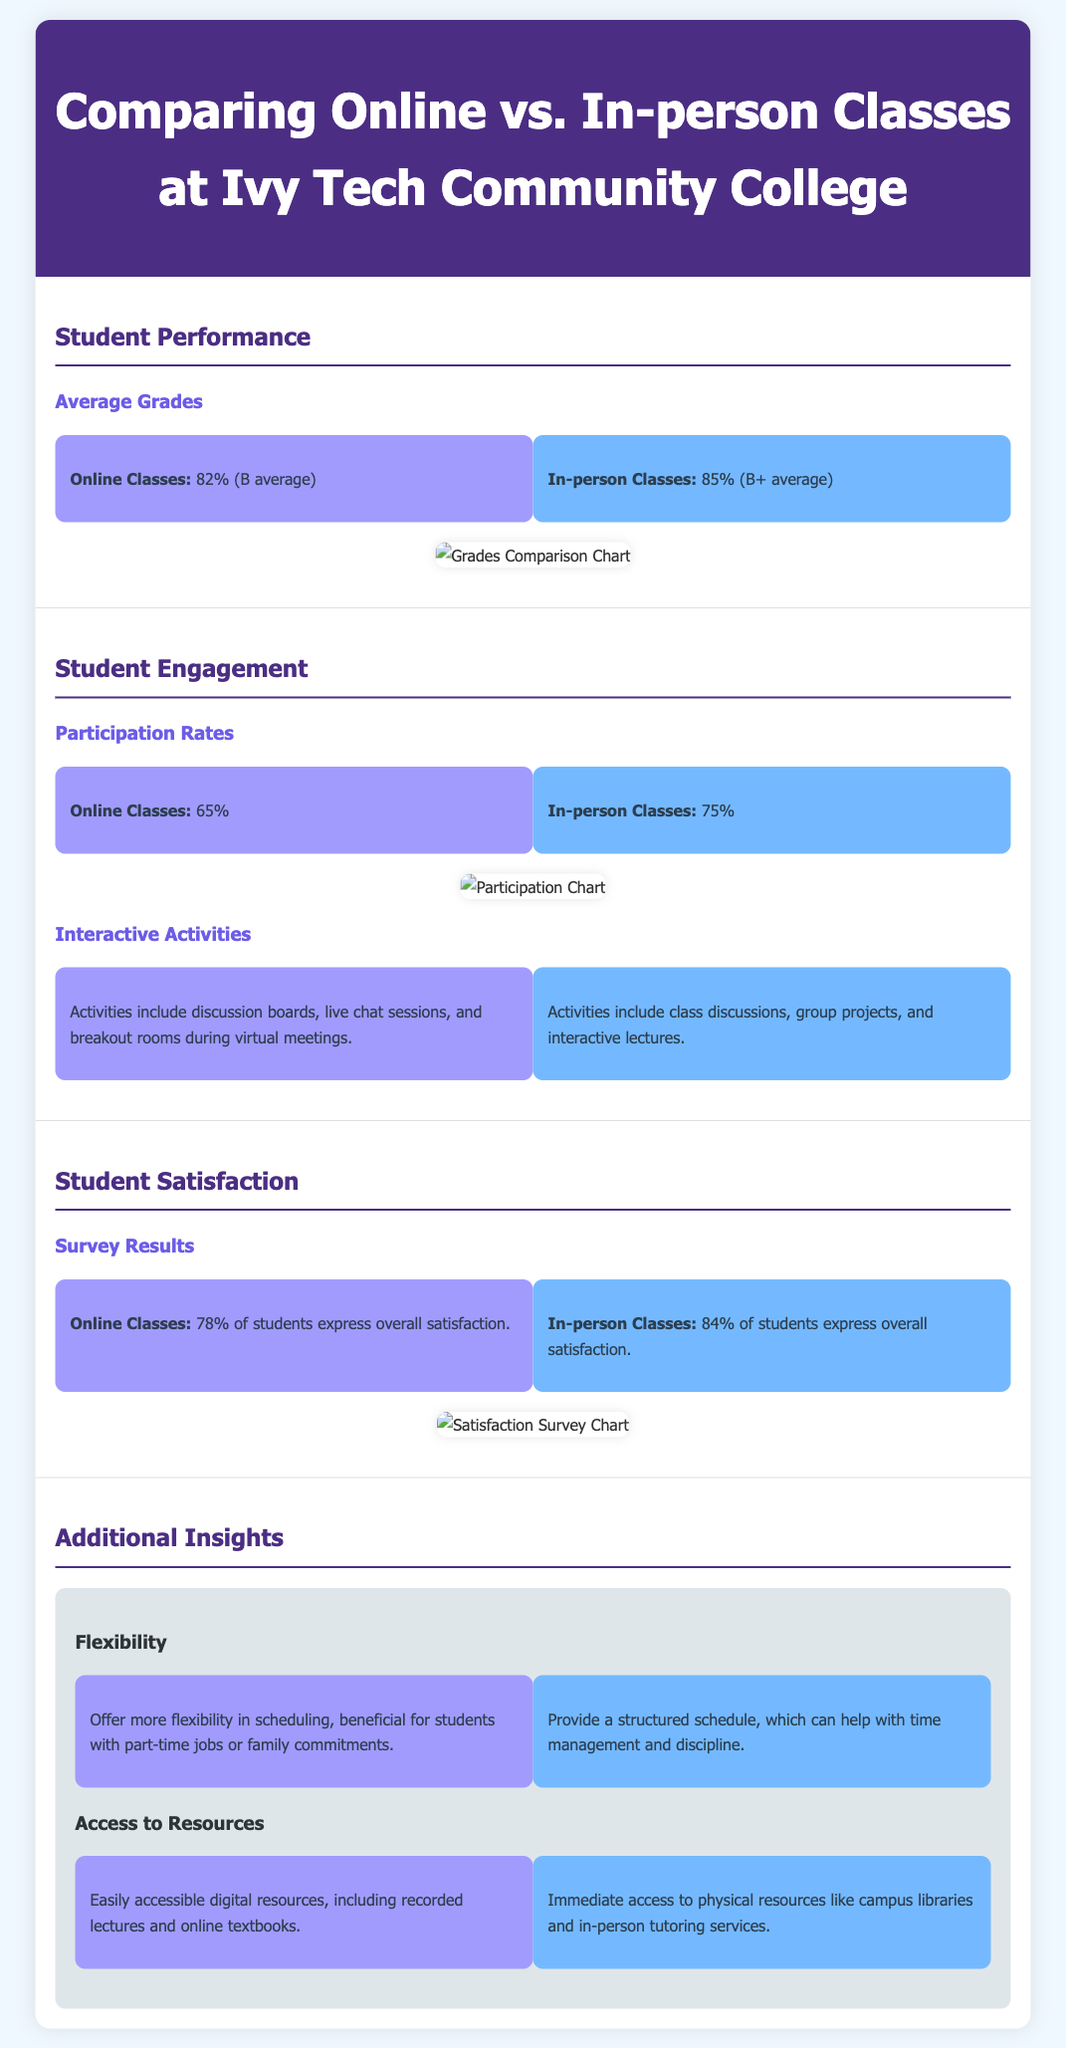What are the average grades for online classes? The average grades for online classes is mentioned as 82%, which corresponds to a B average.
Answer: 82% What is the participation rate for in-person classes? The participation rate for in-person classes is provided as 75%.
Answer: 75% What percentage of students express overall satisfaction with online classes? The document states that 78% of students express overall satisfaction with online classes.
Answer: 78% Which class format has a higher average grade? The comparison indicates that in-person classes have a higher average grade of 85% compared to 82% for online classes.
Answer: In-person classes What type of interactive activities are included in online classes? The document lists discussion boards, live chat sessions, and breakout rooms as activities in online classes.
Answer: Discussion boards, live chat sessions, and breakout rooms How does flexibility compare between online and in-person classes? The document details that online classes offer more flexibility, while in-person classes provide a structured schedule.
Answer: More flexibility What is the overall student satisfaction percentage for in-person classes? According to the document, 84% of students express overall satisfaction with in-person classes.
Answer: 84% Which class format has a higher participation rate? The comparison shows that in-person classes have a higher participation rate at 75% than online classes at 65%.
Answer: In-person classes What is the benefit of access to resources in online classes? Online classes provide easily accessible digital resources, including recorded lectures and online textbooks.
Answer: Easily accessible digital resources 